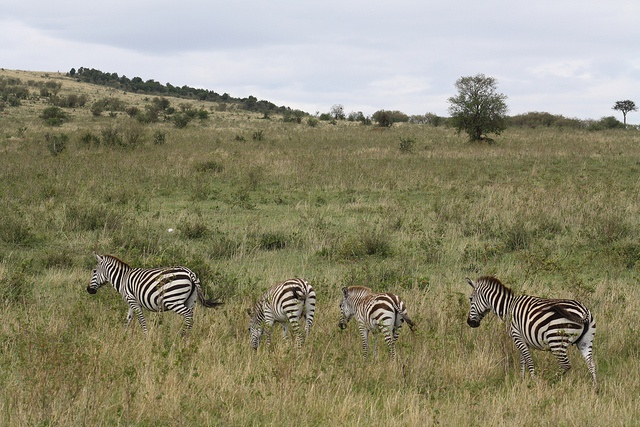Describe the objects in this image and their specific colors. I can see zebra in lightgray, black, gray, darkgray, and olive tones, zebra in lightgray, black, gray, darkgray, and beige tones, zebra in lightgray, gray, olive, and darkgray tones, and zebra in lightgray, gray, darkgray, and olive tones in this image. 